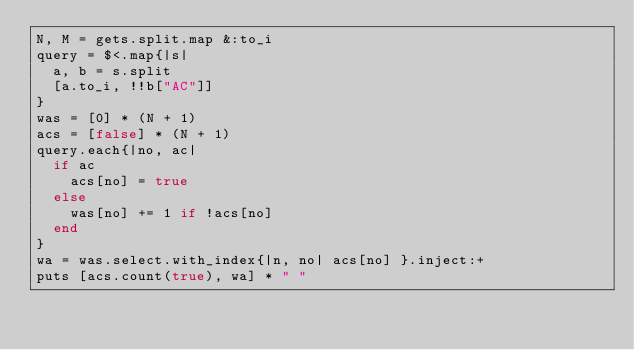Convert code to text. <code><loc_0><loc_0><loc_500><loc_500><_Ruby_>N, M = gets.split.map &:to_i
query = $<.map{|s|
  a, b = s.split
  [a.to_i, !!b["AC"]]
}
was = [0] * (N + 1)
acs = [false] * (N + 1)
query.each{|no, ac|
  if ac
    acs[no] = true
  else
    was[no] += 1 if !acs[no]
  end
}
wa = was.select.with_index{|n, no| acs[no] }.inject:+
puts [acs.count(true), wa] * " "</code> 